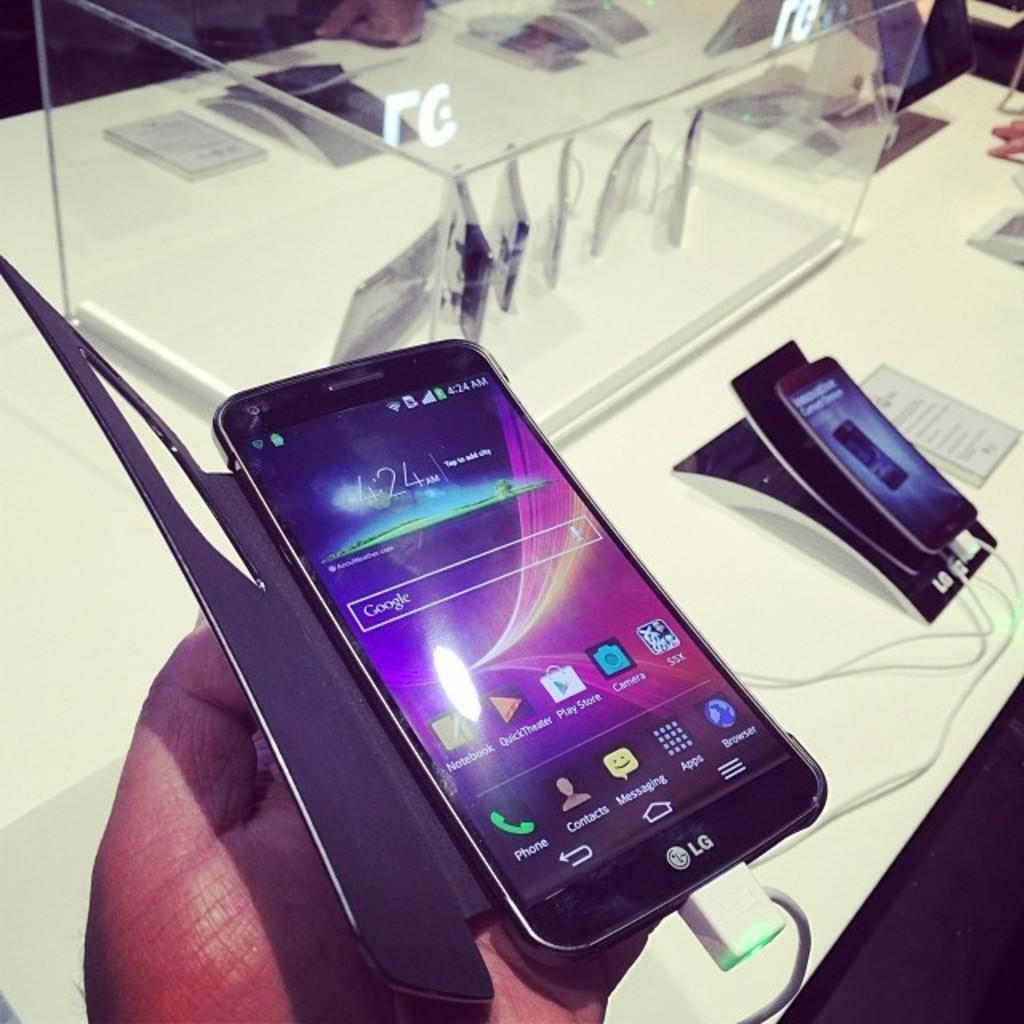<image>
Summarize the visual content of the image. A hand holding an LG branded cell phone with an icon for the play stor on it. 